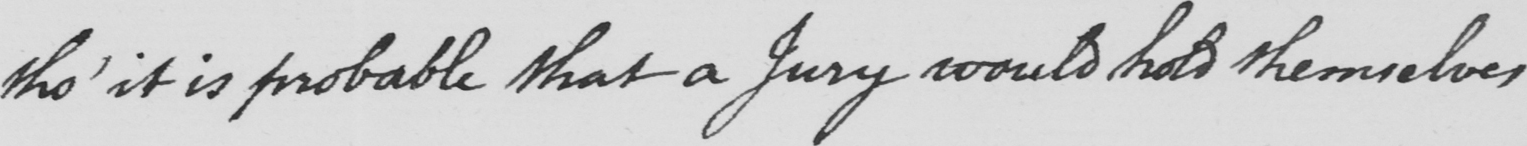Please transcribe the handwritten text in this image. tho '  it is probable that a Jury would hold themselves 